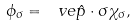<formula> <loc_0><loc_0><loc_500><loc_500>\phi _ { \sigma } = \ v e { \hat { p } } \cdot \sigma \chi _ { \sigma } ,</formula> 